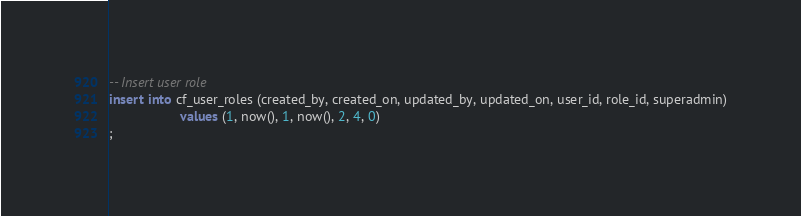Convert code to text. <code><loc_0><loc_0><loc_500><loc_500><_SQL_>-- Insert user role
insert into cf_user_roles (created_by, created_on, updated_by, updated_on, user_id, role_id, superadmin)
                   values (1, now(), 1, now(), 2, 4, 0)
;
</code> 